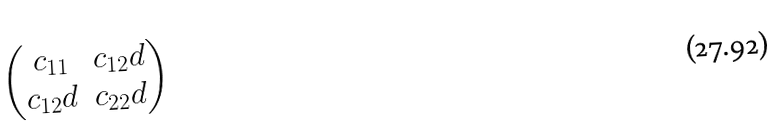Convert formula to latex. <formula><loc_0><loc_0><loc_500><loc_500>\begin{pmatrix} c _ { 1 1 } & c _ { 1 2 } d \\ c _ { 1 2 } d & c _ { 2 2 } d \end{pmatrix}</formula> 